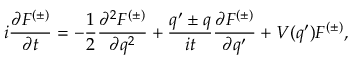<formula> <loc_0><loc_0><loc_500><loc_500>i \frac { \partial F ^ { ( \pm ) } } { \partial t } = - \frac { 1 } { 2 } \frac { \partial ^ { 2 } F ^ { ( \pm ) } } { \partial q ^ { 2 } } + \frac { q ^ { \prime } \pm q } { i t } \frac { \partial F ^ { ( \pm ) } } { \partial q ^ { \prime } } + V ( q ^ { \prime } ) F ^ { ( \pm ) } ,</formula> 